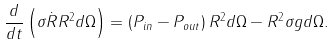<formula> <loc_0><loc_0><loc_500><loc_500>\frac { d } { d t } \left ( \sigma \dot { R } R ^ { 2 } d \Omega \right ) = \left ( P _ { i n } - P _ { o u t } \right ) R ^ { 2 } d \Omega - R ^ { 2 } \sigma g d \Omega .</formula> 